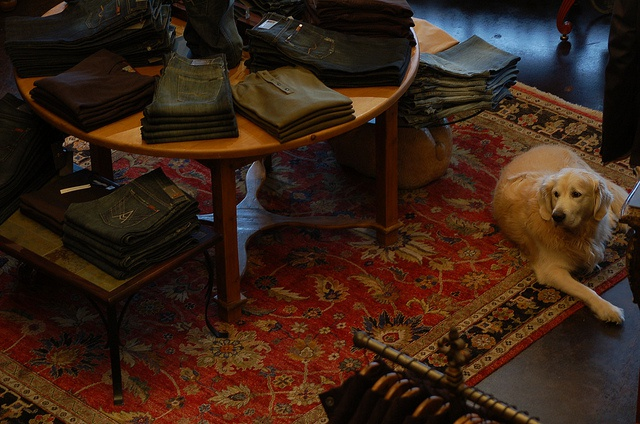Describe the objects in this image and their specific colors. I can see dining table in black, maroon, brown, and gray tones and dog in black, maroon, olive, and gray tones in this image. 